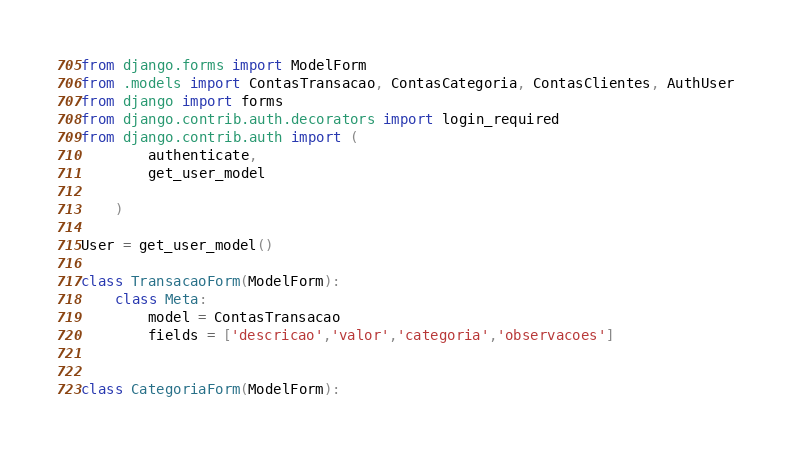Convert code to text. <code><loc_0><loc_0><loc_500><loc_500><_Python_>from django.forms import ModelForm
from .models import ContasTransacao, ContasCategoria, ContasClientes, AuthUser
from django import forms
from django.contrib.auth.decorators import login_required
from django.contrib.auth import (
        authenticate,
        get_user_model

    )

User = get_user_model()

class TransacaoForm(ModelForm):
    class Meta:
        model = ContasTransacao
        fields = ['descricao','valor','categoria','observacoes']


class CategoriaForm(ModelForm):</code> 